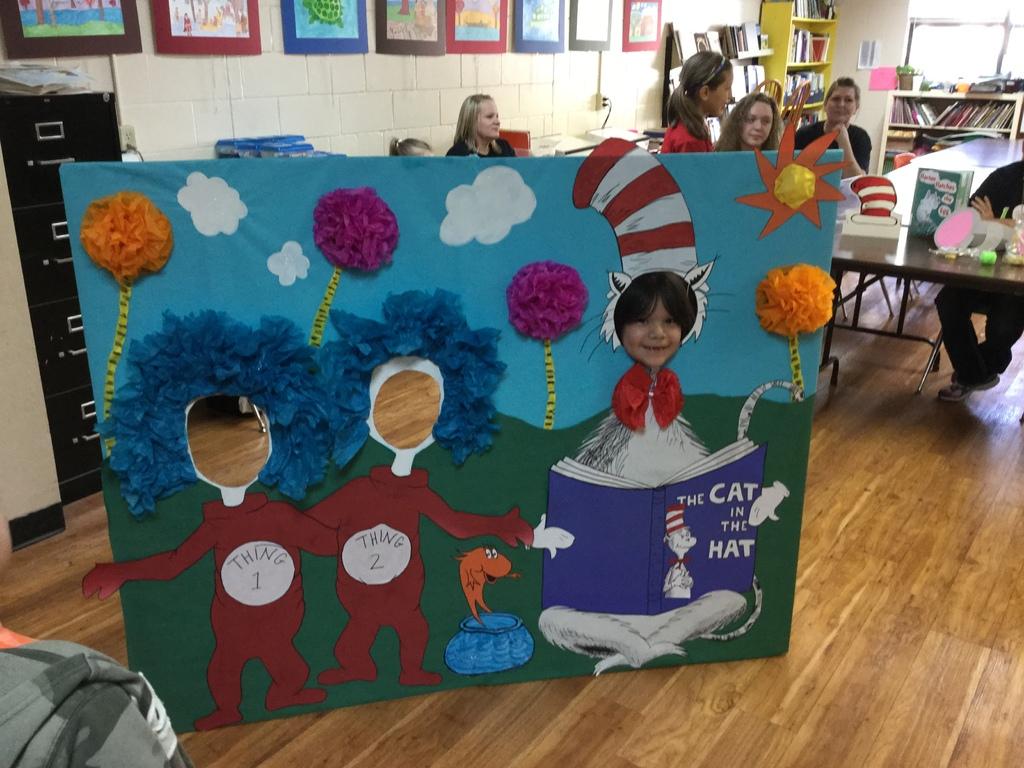What are the two characters in brown?
Ensure brevity in your answer.  Thing 1 and thing 2. 